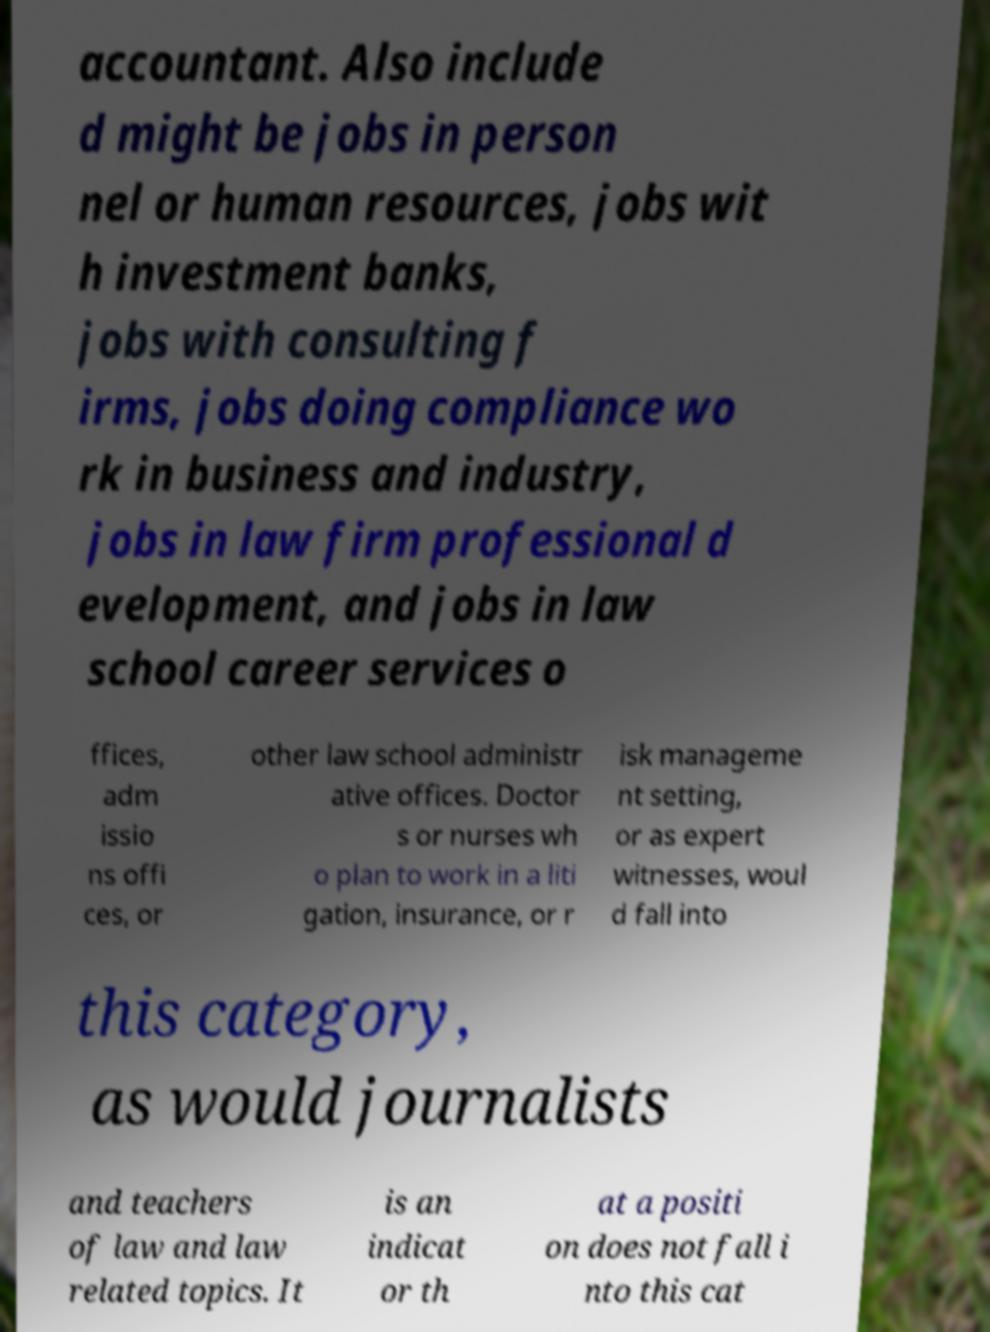For documentation purposes, I need the text within this image transcribed. Could you provide that? accountant. Also include d might be jobs in person nel or human resources, jobs wit h investment banks, jobs with consulting f irms, jobs doing compliance wo rk in business and industry, jobs in law firm professional d evelopment, and jobs in law school career services o ffices, adm issio ns offi ces, or other law school administr ative offices. Doctor s or nurses wh o plan to work in a liti gation, insurance, or r isk manageme nt setting, or as expert witnesses, woul d fall into this category, as would journalists and teachers of law and law related topics. It is an indicat or th at a positi on does not fall i nto this cat 